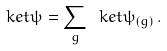<formula> <loc_0><loc_0><loc_500><loc_500>\ k e t { \psi } = \sum _ { g } \ k e t { \psi _ { ( g ) } } \, .</formula> 